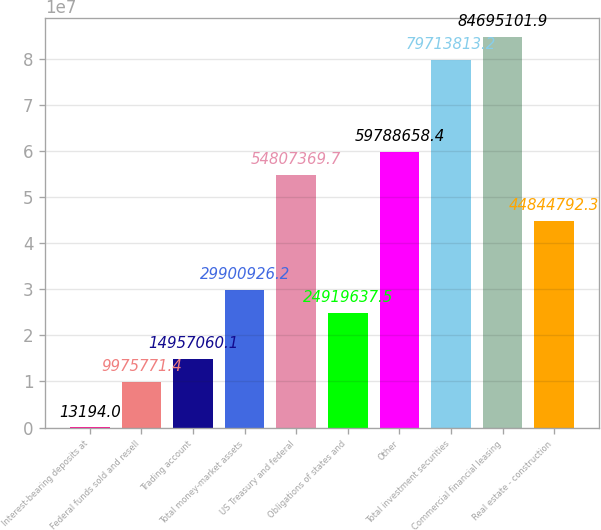Convert chart to OTSL. <chart><loc_0><loc_0><loc_500><loc_500><bar_chart><fcel>Interest-bearing deposits at<fcel>Federal funds sold and resell<fcel>Trading account<fcel>Total money-market assets<fcel>US Treasury and federal<fcel>Obligations of states and<fcel>Other<fcel>Total investment securities<fcel>Commercial financial leasing<fcel>Real estate - construction<nl><fcel>13194<fcel>9.97577e+06<fcel>1.49571e+07<fcel>2.99009e+07<fcel>5.48074e+07<fcel>2.49196e+07<fcel>5.97887e+07<fcel>7.97138e+07<fcel>8.46951e+07<fcel>4.48448e+07<nl></chart> 